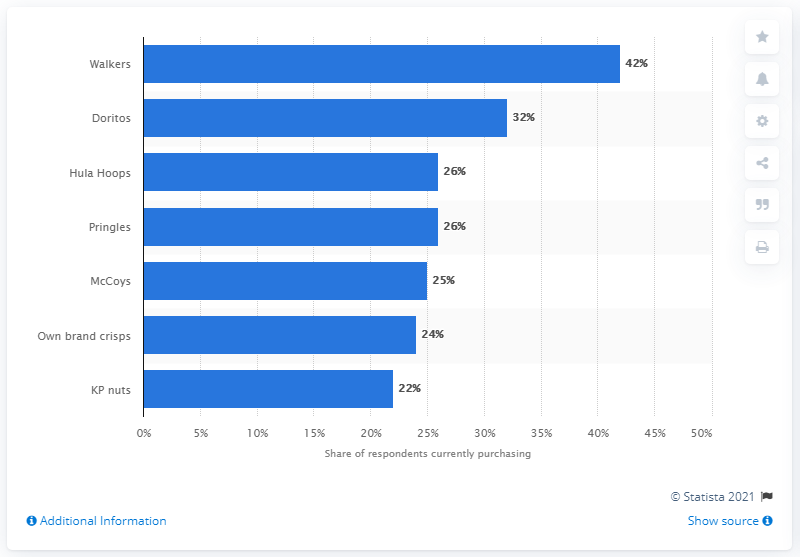Specify some key components in this picture. The second most popular snack brand in the UK was Doritos. 